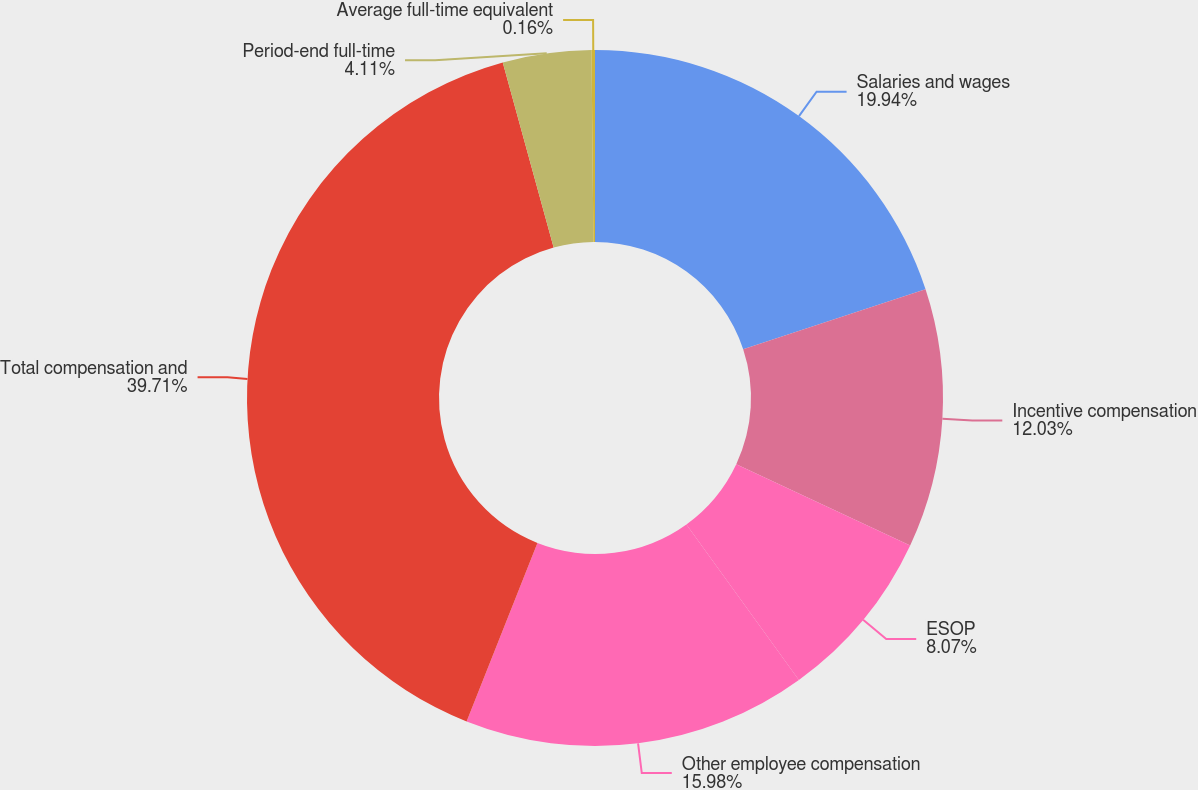Convert chart. <chart><loc_0><loc_0><loc_500><loc_500><pie_chart><fcel>Salaries and wages<fcel>Incentive compensation<fcel>ESOP<fcel>Other employee compensation<fcel>Total compensation and<fcel>Period-end full-time<fcel>Average full-time equivalent<nl><fcel>19.94%<fcel>12.03%<fcel>8.07%<fcel>15.98%<fcel>39.72%<fcel>4.11%<fcel>0.16%<nl></chart> 